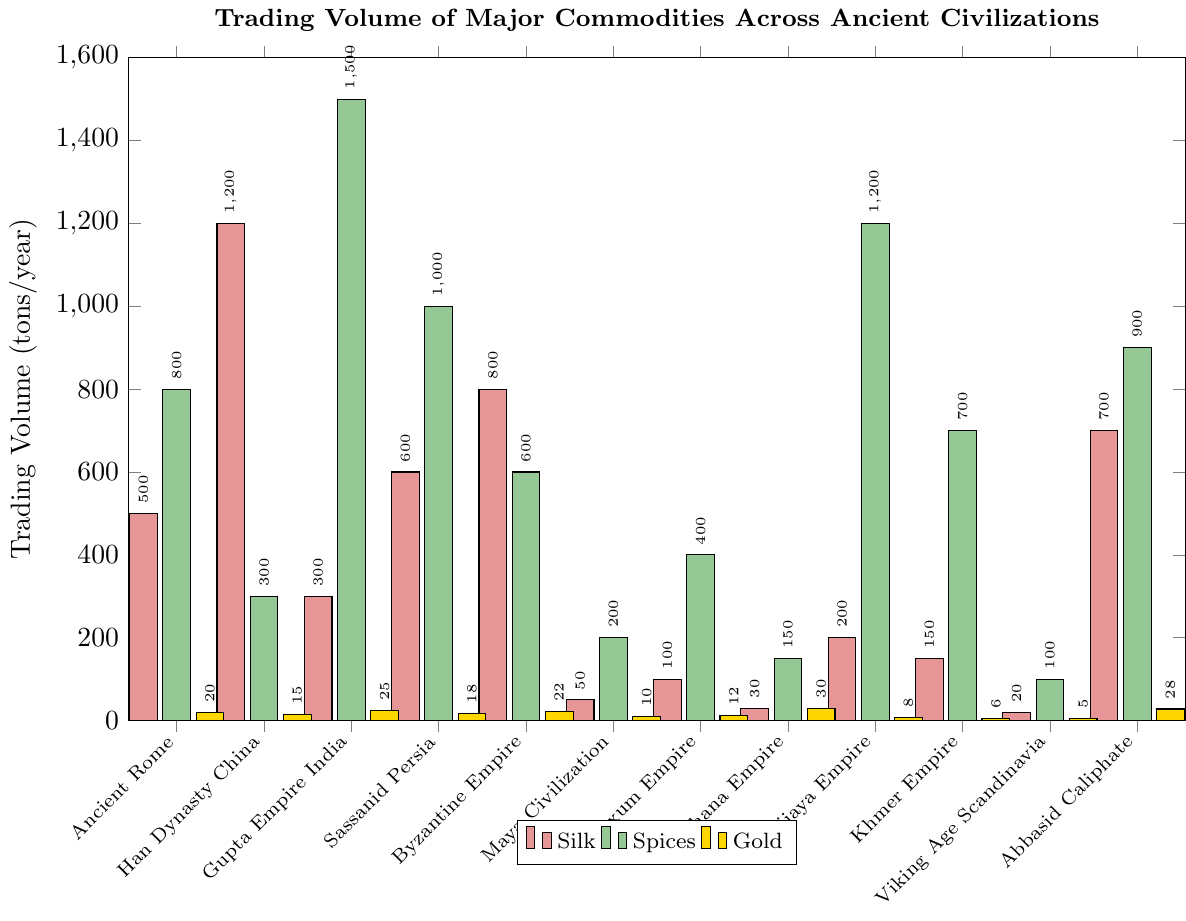Which civilization had the highest trading volume in silk? The Han Dynasty China has the highest bar in the 'silk' category. Compare the height of each bar for silk across the civilizations and observe that the Han Dynasty China bar is the highest.
Answer: Han Dynasty China Which commodity did the Gupta Empire trade in the highest volume? Compare the heights of the three different bars (silk, spices, gold) for the Gupta Empire. The 'spices' bar is the tallest among the three.
Answer: Spices What is the total trading volume of spices and gold for the Abbasid Caliphate? Identify the heights of the 'spices' (900 metric tons) and 'gold' (28 metric tons) bars for the Abbasid Caliphate and sum them up. 900 + 28 = 928 metric tons.
Answer: 928 metric tons Which civilization had the lowest trading volume in silk? Identify the smallest bar in the 'silk' category. The Viking Age Scandinavia has the lowest bar for silk among all civilizations.
Answer: Viking Age Scandinavia By how much is the trading volume of spices in the Sassanid Persia greater than in the Byzantine Empire? Identify the heights of the 'spices' bars for Sassanid Persia (1000 metric tons) and Byzantine Empire (600 metric tons) and compute the difference. 1000 - 600 = 400 metric tons.
Answer: 400 metric tons Which civilization had roughly equal trading volumes of silk and gold? Compare the heights of the 'silk' and 'gold' bars for each civilization. The Byzantine Empire demonstrates roughly equal trading volumes for silk and gold (silk: 800 tons, gold: 22 tons).
Answer: Byzantine Empire What is the average trading volume of gold across all civilizations? Sum up the trading volumes of gold (20 + 15 + 25 + 18 + 22 + 10 + 12 + 30 + 8 + 6 + 5 + 28 = 199 metric tons) and divide by the number of civilizations (12). 199 / 12 ≈ 16.58 metric tons.
Answer: 16.58 metric tons Which civilization traded more spices: the Srivijaya Empire or the Gupta Empire? Compare the heights of the 'spices' bars for Srivijaya Empire (1200 metric tons) and Gupta Empire (1500 metric tons). The Gupta Empire's bar is taller.
Answer: Gupta Empire What is the combined total trading volume of silk and spices for the Han Dynasty China? Add the heights of the 'silk' (1200 metric tons) and 'spices' (300 metric tons) bars for Han Dynasty China. 1200 + 300 = 1500 metric tons.
Answer: 1500 metric tons 